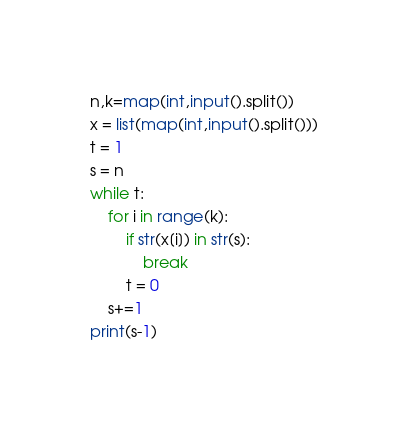Convert code to text. <code><loc_0><loc_0><loc_500><loc_500><_Python_>n,k=map(int,input().split())
x = list(map(int,input().split()))
t = 1
s = n
while t:
    for i in range(k):
        if str(x[i]) in str(s):
            break
        t = 0
    s+=1
print(s-1)</code> 